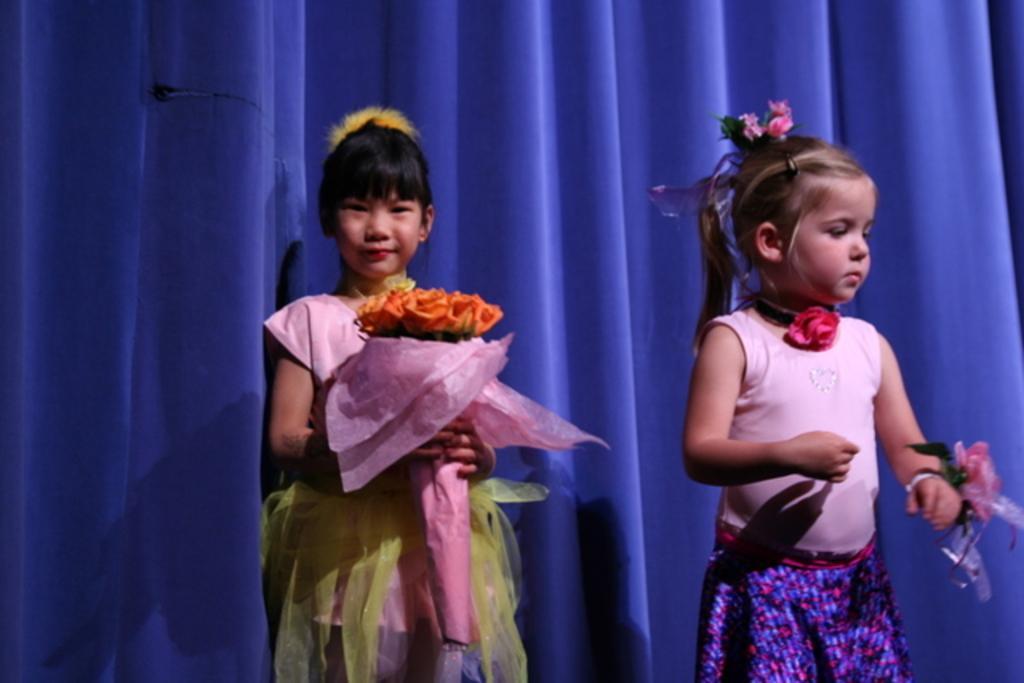Describe this image in one or two sentences. In the picture we can see two girls are standing in a different costume, one girl is holding a flower bookey with orange color flowers and pink color cover to it and one girl is tied with a flower in her hand and behind them we can see the blue color curtain. 